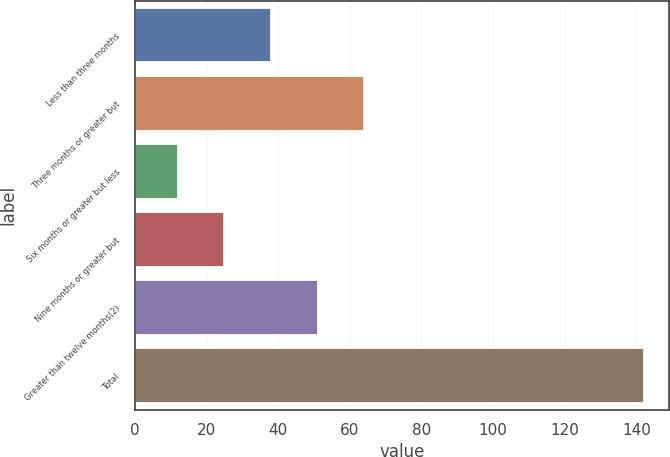Convert chart to OTSL. <chart><loc_0><loc_0><loc_500><loc_500><bar_chart><fcel>Less than three months<fcel>Three months or greater but<fcel>Six months or greater but less<fcel>Nine months or greater but<fcel>Greater than twelve months(2)<fcel>Total<nl><fcel>38<fcel>64<fcel>12<fcel>25<fcel>51<fcel>142<nl></chart> 